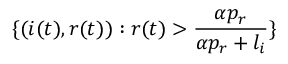Convert formula to latex. <formula><loc_0><loc_0><loc_500><loc_500>\{ ( i ( t ) , r ( t ) ) \colon r ( t ) > \frac { \alpha p _ { r } } { \alpha p _ { r } + l _ { i } } \}</formula> 